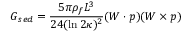<formula> <loc_0><loc_0><loc_500><loc_500>G _ { s e d } = \frac { 5 \pi \rho _ { f } L ^ { 3 } } { 2 4 ( \ln 2 \kappa ) ^ { 2 } } ( W \cdot p ) ( W \times p )</formula> 